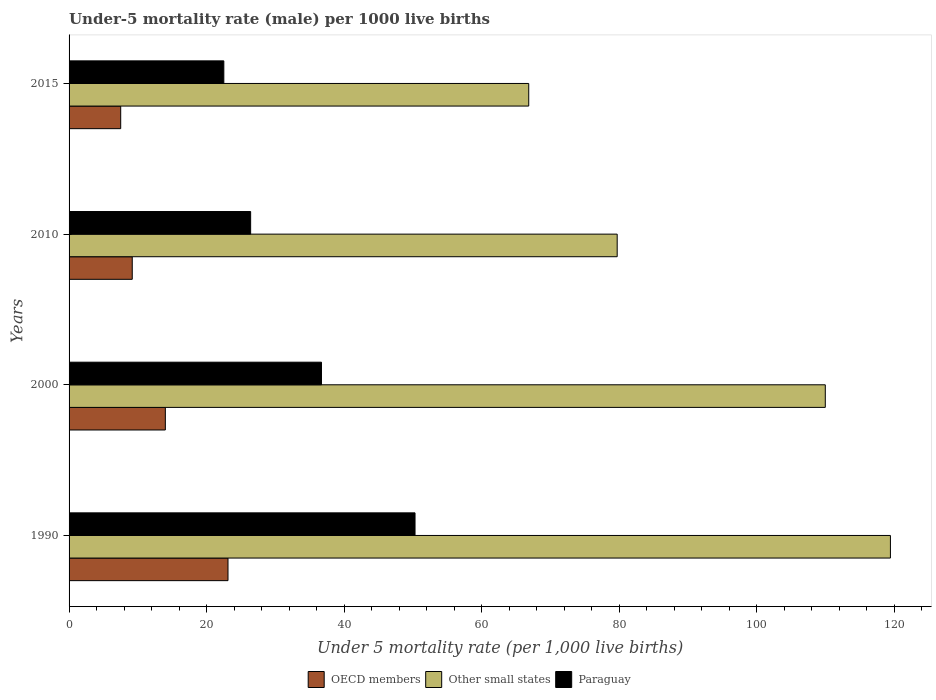How many different coloured bars are there?
Keep it short and to the point. 3. How many bars are there on the 4th tick from the top?
Your answer should be compact. 3. What is the label of the 2nd group of bars from the top?
Your response must be concise. 2010. What is the under-five mortality rate in Other small states in 2015?
Make the answer very short. 66.83. Across all years, what is the maximum under-five mortality rate in Other small states?
Keep it short and to the point. 119.42. Across all years, what is the minimum under-five mortality rate in OECD members?
Your response must be concise. 7.51. In which year was the under-five mortality rate in Paraguay maximum?
Provide a succinct answer. 1990. In which year was the under-five mortality rate in OECD members minimum?
Ensure brevity in your answer.  2015. What is the total under-five mortality rate in OECD members in the graph?
Keep it short and to the point. 53.8. What is the difference between the under-five mortality rate in Paraguay in 2010 and that in 2015?
Make the answer very short. 3.9. What is the difference between the under-five mortality rate in OECD members in 1990 and the under-five mortality rate in Other small states in 2000?
Your answer should be very brief. -86.84. What is the average under-five mortality rate in Other small states per year?
Your response must be concise. 93.97. In the year 1990, what is the difference between the under-five mortality rate in Other small states and under-five mortality rate in Paraguay?
Provide a short and direct response. 69.12. In how many years, is the under-five mortality rate in Other small states greater than 112 ?
Offer a terse response. 1. What is the ratio of the under-five mortality rate in Paraguay in 2000 to that in 2010?
Offer a terse response. 1.39. Is the under-five mortality rate in OECD members in 2010 less than that in 2015?
Make the answer very short. No. Is the difference between the under-five mortality rate in Other small states in 1990 and 2015 greater than the difference between the under-five mortality rate in Paraguay in 1990 and 2015?
Keep it short and to the point. Yes. What is the difference between the highest and the second highest under-five mortality rate in OECD members?
Your response must be concise. 9.11. What is the difference between the highest and the lowest under-five mortality rate in Other small states?
Make the answer very short. 52.59. What does the 1st bar from the top in 2000 represents?
Ensure brevity in your answer.  Paraguay. What does the 3rd bar from the bottom in 2010 represents?
Ensure brevity in your answer.  Paraguay. Is it the case that in every year, the sum of the under-five mortality rate in Other small states and under-five mortality rate in Paraguay is greater than the under-five mortality rate in OECD members?
Ensure brevity in your answer.  Yes. How many bars are there?
Offer a terse response. 12. How many years are there in the graph?
Your response must be concise. 4. What is the difference between two consecutive major ticks on the X-axis?
Provide a succinct answer. 20. Does the graph contain any zero values?
Provide a succinct answer. No. Where does the legend appear in the graph?
Provide a succinct answer. Bottom center. How many legend labels are there?
Provide a succinct answer. 3. How are the legend labels stacked?
Your response must be concise. Horizontal. What is the title of the graph?
Make the answer very short. Under-5 mortality rate (male) per 1000 live births. What is the label or title of the X-axis?
Provide a succinct answer. Under 5 mortality rate (per 1,0 live births). What is the label or title of the Y-axis?
Give a very brief answer. Years. What is the Under 5 mortality rate (per 1,000 live births) of OECD members in 1990?
Offer a very short reply. 23.11. What is the Under 5 mortality rate (per 1,000 live births) of Other small states in 1990?
Keep it short and to the point. 119.42. What is the Under 5 mortality rate (per 1,000 live births) of Paraguay in 1990?
Your response must be concise. 50.3. What is the Under 5 mortality rate (per 1,000 live births) in OECD members in 2000?
Provide a short and direct response. 14. What is the Under 5 mortality rate (per 1,000 live births) in Other small states in 2000?
Offer a terse response. 109.95. What is the Under 5 mortality rate (per 1,000 live births) of Paraguay in 2000?
Offer a terse response. 36.7. What is the Under 5 mortality rate (per 1,000 live births) of OECD members in 2010?
Provide a short and direct response. 9.19. What is the Under 5 mortality rate (per 1,000 live births) in Other small states in 2010?
Offer a very short reply. 79.69. What is the Under 5 mortality rate (per 1,000 live births) of Paraguay in 2010?
Your answer should be very brief. 26.4. What is the Under 5 mortality rate (per 1,000 live births) of OECD members in 2015?
Your answer should be compact. 7.51. What is the Under 5 mortality rate (per 1,000 live births) in Other small states in 2015?
Offer a very short reply. 66.83. What is the Under 5 mortality rate (per 1,000 live births) of Paraguay in 2015?
Give a very brief answer. 22.5. Across all years, what is the maximum Under 5 mortality rate (per 1,000 live births) in OECD members?
Ensure brevity in your answer.  23.11. Across all years, what is the maximum Under 5 mortality rate (per 1,000 live births) in Other small states?
Your response must be concise. 119.42. Across all years, what is the maximum Under 5 mortality rate (per 1,000 live births) of Paraguay?
Provide a short and direct response. 50.3. Across all years, what is the minimum Under 5 mortality rate (per 1,000 live births) of OECD members?
Ensure brevity in your answer.  7.51. Across all years, what is the minimum Under 5 mortality rate (per 1,000 live births) of Other small states?
Offer a very short reply. 66.83. Across all years, what is the minimum Under 5 mortality rate (per 1,000 live births) in Paraguay?
Keep it short and to the point. 22.5. What is the total Under 5 mortality rate (per 1,000 live births) in OECD members in the graph?
Ensure brevity in your answer.  53.8. What is the total Under 5 mortality rate (per 1,000 live births) in Other small states in the graph?
Offer a very short reply. 375.9. What is the total Under 5 mortality rate (per 1,000 live births) in Paraguay in the graph?
Your response must be concise. 135.9. What is the difference between the Under 5 mortality rate (per 1,000 live births) in OECD members in 1990 and that in 2000?
Provide a succinct answer. 9.11. What is the difference between the Under 5 mortality rate (per 1,000 live births) in Other small states in 1990 and that in 2000?
Provide a short and direct response. 9.47. What is the difference between the Under 5 mortality rate (per 1,000 live births) of Paraguay in 1990 and that in 2000?
Ensure brevity in your answer.  13.6. What is the difference between the Under 5 mortality rate (per 1,000 live births) in OECD members in 1990 and that in 2010?
Offer a terse response. 13.92. What is the difference between the Under 5 mortality rate (per 1,000 live births) of Other small states in 1990 and that in 2010?
Provide a succinct answer. 39.73. What is the difference between the Under 5 mortality rate (per 1,000 live births) in Paraguay in 1990 and that in 2010?
Keep it short and to the point. 23.9. What is the difference between the Under 5 mortality rate (per 1,000 live births) in OECD members in 1990 and that in 2015?
Make the answer very short. 15.6. What is the difference between the Under 5 mortality rate (per 1,000 live births) of Other small states in 1990 and that in 2015?
Provide a short and direct response. 52.59. What is the difference between the Under 5 mortality rate (per 1,000 live births) of Paraguay in 1990 and that in 2015?
Your answer should be very brief. 27.8. What is the difference between the Under 5 mortality rate (per 1,000 live births) of OECD members in 2000 and that in 2010?
Your answer should be very brief. 4.81. What is the difference between the Under 5 mortality rate (per 1,000 live births) in Other small states in 2000 and that in 2010?
Your answer should be very brief. 30.26. What is the difference between the Under 5 mortality rate (per 1,000 live births) of Paraguay in 2000 and that in 2010?
Your answer should be very brief. 10.3. What is the difference between the Under 5 mortality rate (per 1,000 live births) of OECD members in 2000 and that in 2015?
Offer a very short reply. 6.49. What is the difference between the Under 5 mortality rate (per 1,000 live births) of Other small states in 2000 and that in 2015?
Make the answer very short. 43.12. What is the difference between the Under 5 mortality rate (per 1,000 live births) of Paraguay in 2000 and that in 2015?
Ensure brevity in your answer.  14.2. What is the difference between the Under 5 mortality rate (per 1,000 live births) of OECD members in 2010 and that in 2015?
Ensure brevity in your answer.  1.68. What is the difference between the Under 5 mortality rate (per 1,000 live births) of Other small states in 2010 and that in 2015?
Keep it short and to the point. 12.86. What is the difference between the Under 5 mortality rate (per 1,000 live births) of OECD members in 1990 and the Under 5 mortality rate (per 1,000 live births) of Other small states in 2000?
Ensure brevity in your answer.  -86.84. What is the difference between the Under 5 mortality rate (per 1,000 live births) of OECD members in 1990 and the Under 5 mortality rate (per 1,000 live births) of Paraguay in 2000?
Make the answer very short. -13.59. What is the difference between the Under 5 mortality rate (per 1,000 live births) of Other small states in 1990 and the Under 5 mortality rate (per 1,000 live births) of Paraguay in 2000?
Your answer should be very brief. 82.72. What is the difference between the Under 5 mortality rate (per 1,000 live births) in OECD members in 1990 and the Under 5 mortality rate (per 1,000 live births) in Other small states in 2010?
Ensure brevity in your answer.  -56.58. What is the difference between the Under 5 mortality rate (per 1,000 live births) of OECD members in 1990 and the Under 5 mortality rate (per 1,000 live births) of Paraguay in 2010?
Give a very brief answer. -3.29. What is the difference between the Under 5 mortality rate (per 1,000 live births) of Other small states in 1990 and the Under 5 mortality rate (per 1,000 live births) of Paraguay in 2010?
Your answer should be compact. 93.02. What is the difference between the Under 5 mortality rate (per 1,000 live births) of OECD members in 1990 and the Under 5 mortality rate (per 1,000 live births) of Other small states in 2015?
Your answer should be compact. -43.72. What is the difference between the Under 5 mortality rate (per 1,000 live births) in OECD members in 1990 and the Under 5 mortality rate (per 1,000 live births) in Paraguay in 2015?
Make the answer very short. 0.61. What is the difference between the Under 5 mortality rate (per 1,000 live births) in Other small states in 1990 and the Under 5 mortality rate (per 1,000 live births) in Paraguay in 2015?
Provide a succinct answer. 96.92. What is the difference between the Under 5 mortality rate (per 1,000 live births) of OECD members in 2000 and the Under 5 mortality rate (per 1,000 live births) of Other small states in 2010?
Ensure brevity in your answer.  -65.7. What is the difference between the Under 5 mortality rate (per 1,000 live births) of OECD members in 2000 and the Under 5 mortality rate (per 1,000 live births) of Paraguay in 2010?
Ensure brevity in your answer.  -12.4. What is the difference between the Under 5 mortality rate (per 1,000 live births) in Other small states in 2000 and the Under 5 mortality rate (per 1,000 live births) in Paraguay in 2010?
Provide a short and direct response. 83.55. What is the difference between the Under 5 mortality rate (per 1,000 live births) of OECD members in 2000 and the Under 5 mortality rate (per 1,000 live births) of Other small states in 2015?
Keep it short and to the point. -52.83. What is the difference between the Under 5 mortality rate (per 1,000 live births) of OECD members in 2000 and the Under 5 mortality rate (per 1,000 live births) of Paraguay in 2015?
Your answer should be very brief. -8.5. What is the difference between the Under 5 mortality rate (per 1,000 live births) of Other small states in 2000 and the Under 5 mortality rate (per 1,000 live births) of Paraguay in 2015?
Your response must be concise. 87.45. What is the difference between the Under 5 mortality rate (per 1,000 live births) of OECD members in 2010 and the Under 5 mortality rate (per 1,000 live births) of Other small states in 2015?
Your answer should be compact. -57.65. What is the difference between the Under 5 mortality rate (per 1,000 live births) of OECD members in 2010 and the Under 5 mortality rate (per 1,000 live births) of Paraguay in 2015?
Keep it short and to the point. -13.31. What is the difference between the Under 5 mortality rate (per 1,000 live births) in Other small states in 2010 and the Under 5 mortality rate (per 1,000 live births) in Paraguay in 2015?
Keep it short and to the point. 57.19. What is the average Under 5 mortality rate (per 1,000 live births) of OECD members per year?
Your answer should be compact. 13.45. What is the average Under 5 mortality rate (per 1,000 live births) of Other small states per year?
Keep it short and to the point. 93.97. What is the average Under 5 mortality rate (per 1,000 live births) in Paraguay per year?
Provide a succinct answer. 33.98. In the year 1990, what is the difference between the Under 5 mortality rate (per 1,000 live births) of OECD members and Under 5 mortality rate (per 1,000 live births) of Other small states?
Offer a terse response. -96.31. In the year 1990, what is the difference between the Under 5 mortality rate (per 1,000 live births) in OECD members and Under 5 mortality rate (per 1,000 live births) in Paraguay?
Give a very brief answer. -27.19. In the year 1990, what is the difference between the Under 5 mortality rate (per 1,000 live births) of Other small states and Under 5 mortality rate (per 1,000 live births) of Paraguay?
Your answer should be compact. 69.12. In the year 2000, what is the difference between the Under 5 mortality rate (per 1,000 live births) of OECD members and Under 5 mortality rate (per 1,000 live births) of Other small states?
Keep it short and to the point. -95.95. In the year 2000, what is the difference between the Under 5 mortality rate (per 1,000 live births) of OECD members and Under 5 mortality rate (per 1,000 live births) of Paraguay?
Your answer should be compact. -22.7. In the year 2000, what is the difference between the Under 5 mortality rate (per 1,000 live births) in Other small states and Under 5 mortality rate (per 1,000 live births) in Paraguay?
Your answer should be compact. 73.25. In the year 2010, what is the difference between the Under 5 mortality rate (per 1,000 live births) in OECD members and Under 5 mortality rate (per 1,000 live births) in Other small states?
Your answer should be compact. -70.51. In the year 2010, what is the difference between the Under 5 mortality rate (per 1,000 live births) in OECD members and Under 5 mortality rate (per 1,000 live births) in Paraguay?
Offer a very short reply. -17.21. In the year 2010, what is the difference between the Under 5 mortality rate (per 1,000 live births) of Other small states and Under 5 mortality rate (per 1,000 live births) of Paraguay?
Keep it short and to the point. 53.29. In the year 2015, what is the difference between the Under 5 mortality rate (per 1,000 live births) of OECD members and Under 5 mortality rate (per 1,000 live births) of Other small states?
Your response must be concise. -59.33. In the year 2015, what is the difference between the Under 5 mortality rate (per 1,000 live births) of OECD members and Under 5 mortality rate (per 1,000 live births) of Paraguay?
Offer a very short reply. -14.99. In the year 2015, what is the difference between the Under 5 mortality rate (per 1,000 live births) in Other small states and Under 5 mortality rate (per 1,000 live births) in Paraguay?
Ensure brevity in your answer.  44.33. What is the ratio of the Under 5 mortality rate (per 1,000 live births) in OECD members in 1990 to that in 2000?
Offer a terse response. 1.65. What is the ratio of the Under 5 mortality rate (per 1,000 live births) of Other small states in 1990 to that in 2000?
Your response must be concise. 1.09. What is the ratio of the Under 5 mortality rate (per 1,000 live births) in Paraguay in 1990 to that in 2000?
Your response must be concise. 1.37. What is the ratio of the Under 5 mortality rate (per 1,000 live births) in OECD members in 1990 to that in 2010?
Your answer should be very brief. 2.52. What is the ratio of the Under 5 mortality rate (per 1,000 live births) of Other small states in 1990 to that in 2010?
Give a very brief answer. 1.5. What is the ratio of the Under 5 mortality rate (per 1,000 live births) of Paraguay in 1990 to that in 2010?
Offer a terse response. 1.91. What is the ratio of the Under 5 mortality rate (per 1,000 live births) in OECD members in 1990 to that in 2015?
Give a very brief answer. 3.08. What is the ratio of the Under 5 mortality rate (per 1,000 live births) of Other small states in 1990 to that in 2015?
Keep it short and to the point. 1.79. What is the ratio of the Under 5 mortality rate (per 1,000 live births) of Paraguay in 1990 to that in 2015?
Provide a succinct answer. 2.24. What is the ratio of the Under 5 mortality rate (per 1,000 live births) of OECD members in 2000 to that in 2010?
Keep it short and to the point. 1.52. What is the ratio of the Under 5 mortality rate (per 1,000 live births) in Other small states in 2000 to that in 2010?
Make the answer very short. 1.38. What is the ratio of the Under 5 mortality rate (per 1,000 live births) of Paraguay in 2000 to that in 2010?
Give a very brief answer. 1.39. What is the ratio of the Under 5 mortality rate (per 1,000 live births) in OECD members in 2000 to that in 2015?
Keep it short and to the point. 1.86. What is the ratio of the Under 5 mortality rate (per 1,000 live births) of Other small states in 2000 to that in 2015?
Your answer should be compact. 1.65. What is the ratio of the Under 5 mortality rate (per 1,000 live births) of Paraguay in 2000 to that in 2015?
Offer a very short reply. 1.63. What is the ratio of the Under 5 mortality rate (per 1,000 live births) in OECD members in 2010 to that in 2015?
Ensure brevity in your answer.  1.22. What is the ratio of the Under 5 mortality rate (per 1,000 live births) of Other small states in 2010 to that in 2015?
Make the answer very short. 1.19. What is the ratio of the Under 5 mortality rate (per 1,000 live births) of Paraguay in 2010 to that in 2015?
Keep it short and to the point. 1.17. What is the difference between the highest and the second highest Under 5 mortality rate (per 1,000 live births) of OECD members?
Give a very brief answer. 9.11. What is the difference between the highest and the second highest Under 5 mortality rate (per 1,000 live births) in Other small states?
Provide a short and direct response. 9.47. What is the difference between the highest and the second highest Under 5 mortality rate (per 1,000 live births) in Paraguay?
Keep it short and to the point. 13.6. What is the difference between the highest and the lowest Under 5 mortality rate (per 1,000 live births) in OECD members?
Make the answer very short. 15.6. What is the difference between the highest and the lowest Under 5 mortality rate (per 1,000 live births) in Other small states?
Your answer should be compact. 52.59. What is the difference between the highest and the lowest Under 5 mortality rate (per 1,000 live births) of Paraguay?
Your answer should be compact. 27.8. 